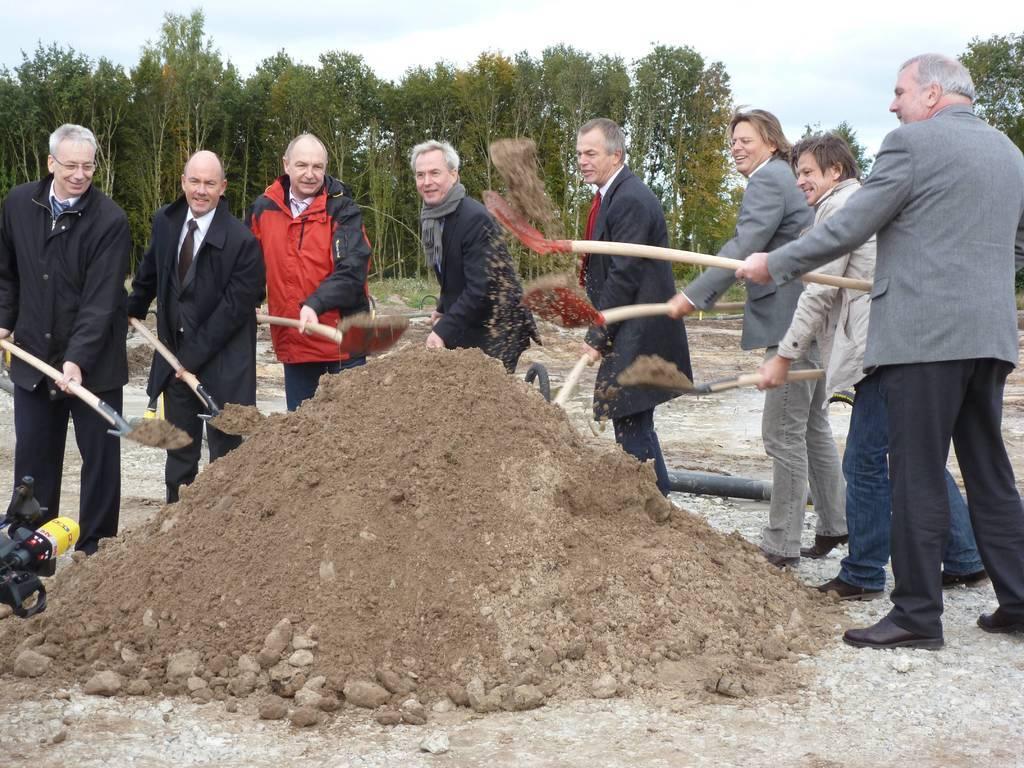Could you give a brief overview of what you see in this image? This picture is clicked outside. In the foreground we can see the mud and the gravels. On the left corner we can see a camera. In the center we can see the group of persons, holding shovels and standing. In the background we can see the sky, trees and many other objects. 